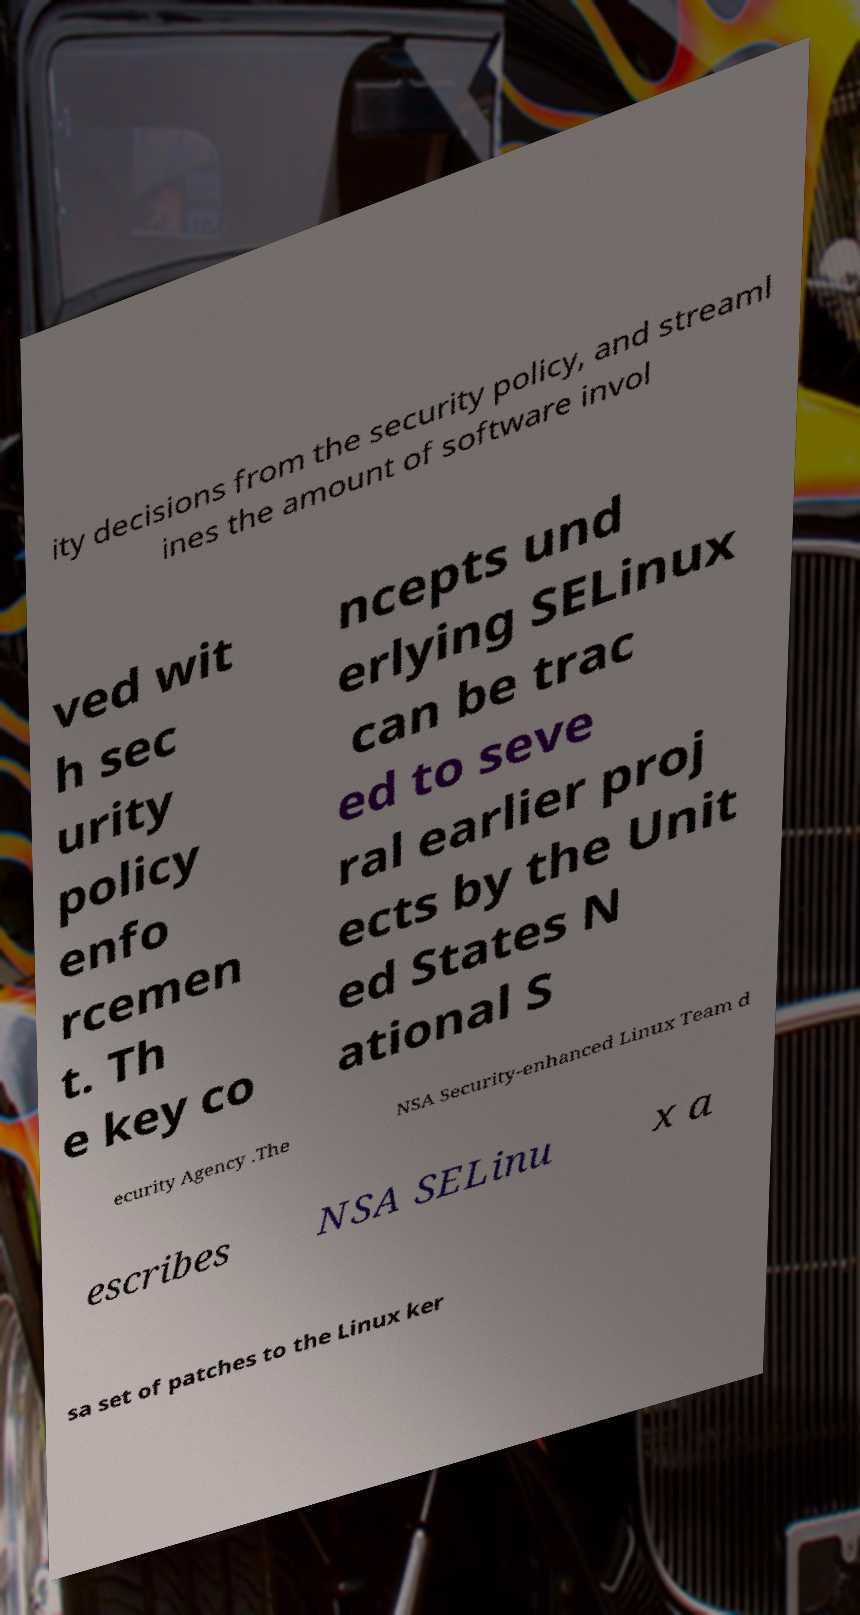Please read and relay the text visible in this image. What does it say? ity decisions from the security policy, and streaml ines the amount of software invol ved wit h sec urity policy enfo rcemen t. Th e key co ncepts und erlying SELinux can be trac ed to seve ral earlier proj ects by the Unit ed States N ational S ecurity Agency .The NSA Security-enhanced Linux Team d escribes NSA SELinu x a sa set of patches to the Linux ker 